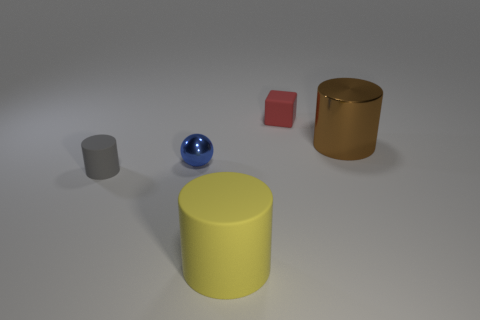Subtract all big rubber cylinders. How many cylinders are left? 2 Add 5 tiny blue metallic balls. How many objects exist? 10 Subtract 1 gray cylinders. How many objects are left? 4 Subtract all cylinders. How many objects are left? 2 Subtract all small red rubber objects. Subtract all yellow matte cylinders. How many objects are left? 3 Add 5 blue metallic objects. How many blue metallic objects are left? 6 Add 1 blue rubber objects. How many blue rubber objects exist? 1 